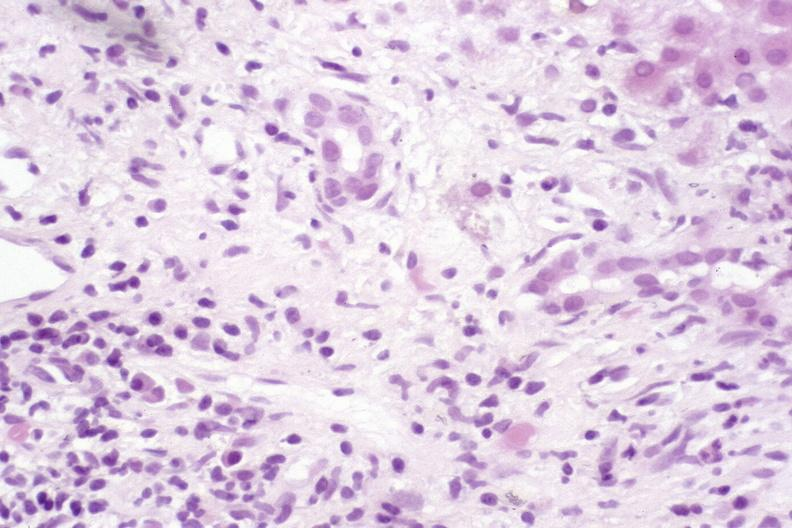s liver present?
Answer the question using a single word or phrase. Yes 